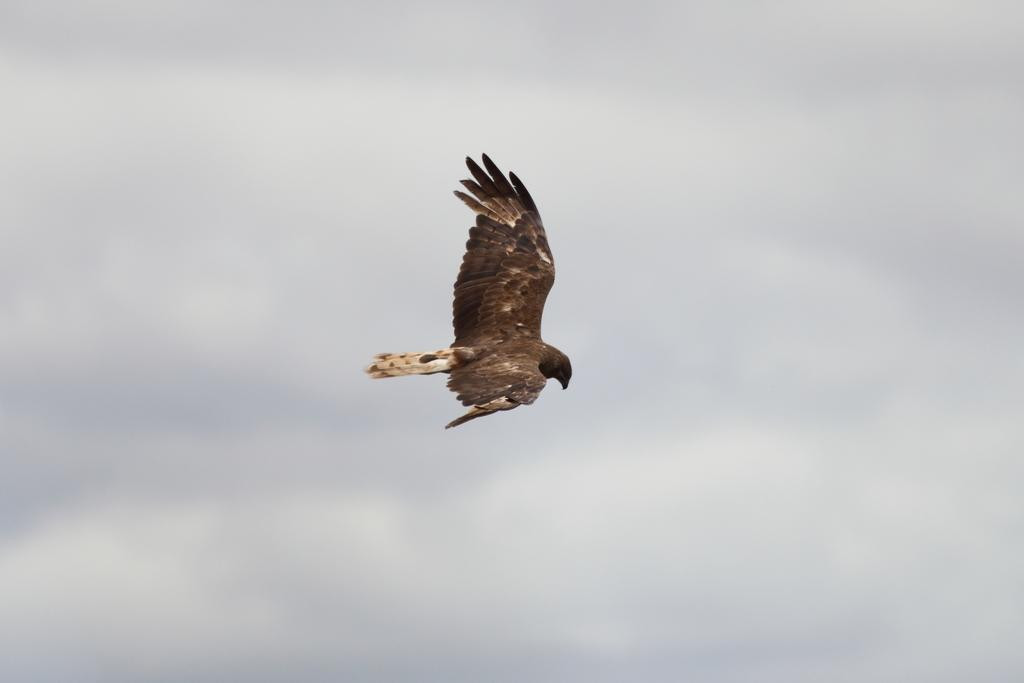What type of animal can be seen in the image? There is a bird in the image. What is the bird doing in the image? The bird is flying in the sky. What type of string is the bird holding in its beak in the image? There is no string visible in the image; the bird is simply flying in the sky. 